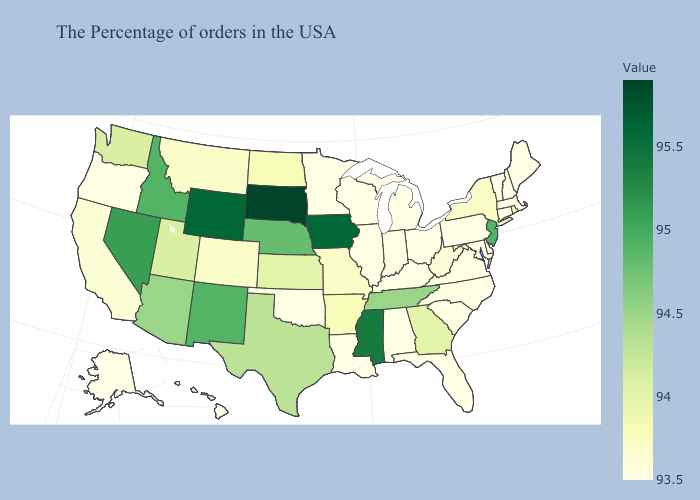Among the states that border Connecticut , which have the lowest value?
Short answer required. Massachusetts. Among the states that border Louisiana , does Arkansas have the highest value?
Write a very short answer. No. Which states hav the highest value in the MidWest?
Concise answer only. South Dakota. Among the states that border Kentucky , does Missouri have the lowest value?
Be succinct. No. Which states have the lowest value in the South?
Keep it brief. Delaware, Maryland, Virginia, North Carolina, South Carolina, Florida, Kentucky, Alabama, Louisiana, Oklahoma. Does the map have missing data?
Short answer required. No. Among the states that border Wyoming , does Nebraska have the highest value?
Keep it brief. No. 